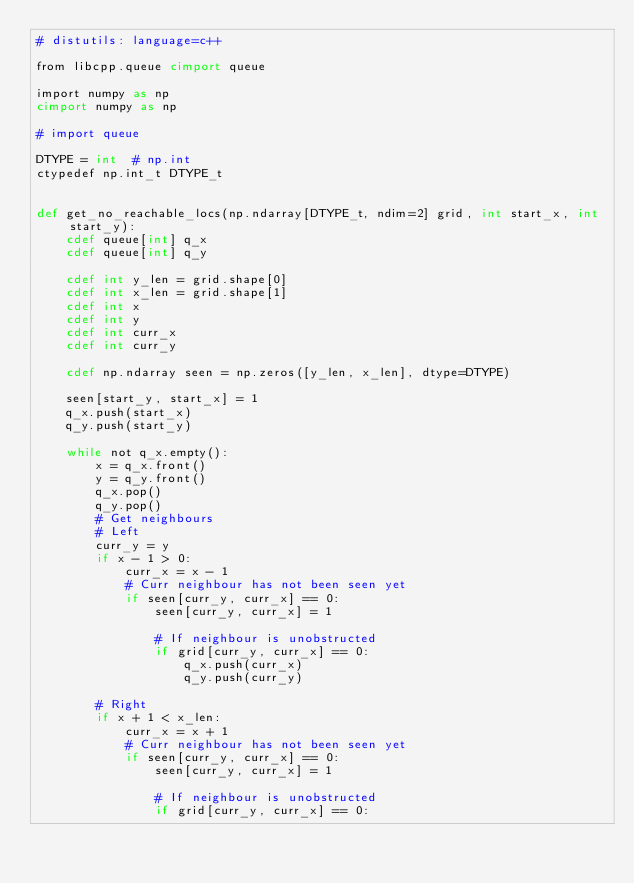<code> <loc_0><loc_0><loc_500><loc_500><_Cython_># distutils: language=c++

from libcpp.queue cimport queue

import numpy as np
cimport numpy as np

# import queue

DTYPE = int  # np.int
ctypedef np.int_t DTYPE_t


def get_no_reachable_locs(np.ndarray[DTYPE_t, ndim=2] grid, int start_x, int start_y):
    cdef queue[int] q_x
    cdef queue[int] q_y

    cdef int y_len = grid.shape[0]
    cdef int x_len = grid.shape[1]
    cdef int x
    cdef int y
    cdef int curr_x
    cdef int curr_y

    cdef np.ndarray seen = np.zeros([y_len, x_len], dtype=DTYPE)

    seen[start_y, start_x] = 1
    q_x.push(start_x)
    q_y.push(start_y)

    while not q_x.empty():
        x = q_x.front()
        y = q_y.front()
        q_x.pop()
        q_y.pop()
        # Get neighbours
        # Left
        curr_y = y
        if x - 1 > 0:
            curr_x = x - 1
            # Curr neighbour has not been seen yet
            if seen[curr_y, curr_x] == 0:
                seen[curr_y, curr_x] = 1

                # If neighbour is unobstructed
                if grid[curr_y, curr_x] == 0:
                    q_x.push(curr_x)
                    q_y.push(curr_y)

        # Right
        if x + 1 < x_len:
            curr_x = x + 1
            # Curr neighbour has not been seen yet
            if seen[curr_y, curr_x] == 0:
                seen[curr_y, curr_x] = 1

                # If neighbour is unobstructed
                if grid[curr_y, curr_x] == 0:</code> 